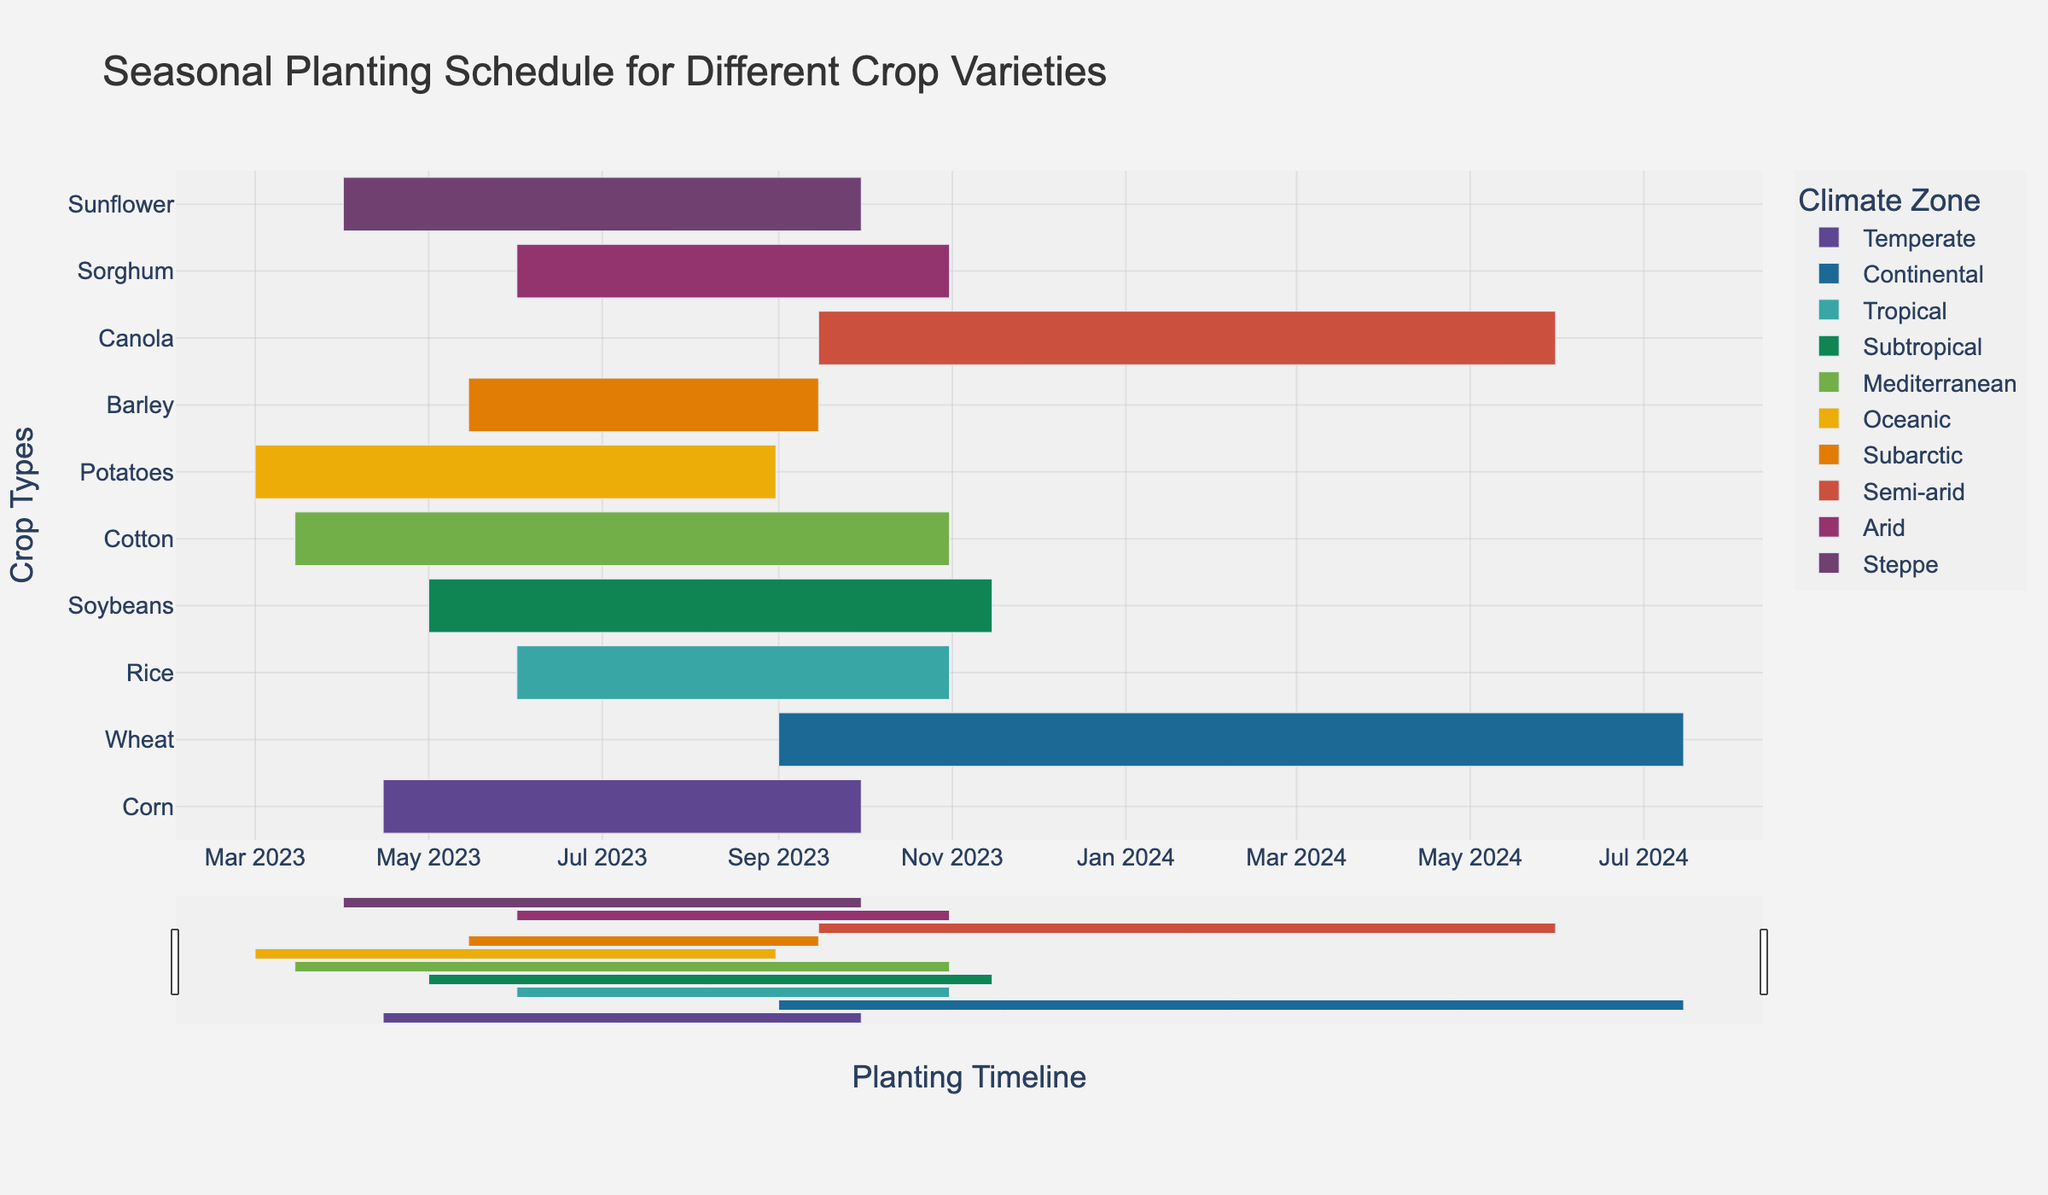What's the title of the figure? The title of the figure is usually displayed at the top and should summarize what the figure represents. Here, the title is "Seasonal Planting Schedule for Different Crop Varieties".
Answer: Seasonal Planting Schedule for Different Crop Varieties What crop has the longest planting period in the Tropical climate zone? To find the crop with the longest planting period in the Tropical climate zone, look at the bars representing the tropical climate. Rice is the only crop listed in the Tropical zone.
Answer: Rice Which crop will be harvested first in the Oceanic climate zone? Look at the end dates of the bars under the Oceanic climate zone. Potatoes in the Oceanic zone end on August 31, 2023.
Answer: Potatoes How many climate zones are represented in the figure? Each bar's color represents different climate zones. Counting all unique climate zones yields 9 distinct climate zones: Temperate, Continental, Tropical, Subtropical, Mediterranean, Oceanic, Subarctic, Semi-arid, Arid, Steppe.
Answer: 10 Which crops are planted during June? Look for bars overlapping the June timeline. These bars include Rice, Soybeans, Sorghum, and Sunflower.
Answer: Rice, Soybeans, Sorghum, and Sunflower Which climate zone has the longest total planting period when combining all included crops? Sum the periods of each crop within each climate zone, and compare. Subtropical (Soybeans), spanning from May to November, singularly has a long period but look at all crops combined in each zone for cumulative length.
Answer: Subtropical Which crops are suitable for planting simultaneously in April in Temperate and Steppe climate zones? Look for bars starting or ongoing in April under Temperate and Steppe zones. Corn (Temperate) and Sunflower (Steppe) both start around April.
Answer: Corn, Sunflower What is the difference in planting periods between Canola in Semi-arid and Wheat in Continental climate zones? Calculate the length of both planting periods by subtracting the start date from the end date. Canola: September to May (~8.5 months), and Wheat: September to July (~10.5 months). Difference: ~2 months.
Answer: 2 months Which crop in the Mediterranean climate zone finishes last? Look at the end dates of the bars in the Mediterranean zone. Cotton, which ends on October 31, 2023, is the latest.
Answer: Cotton 